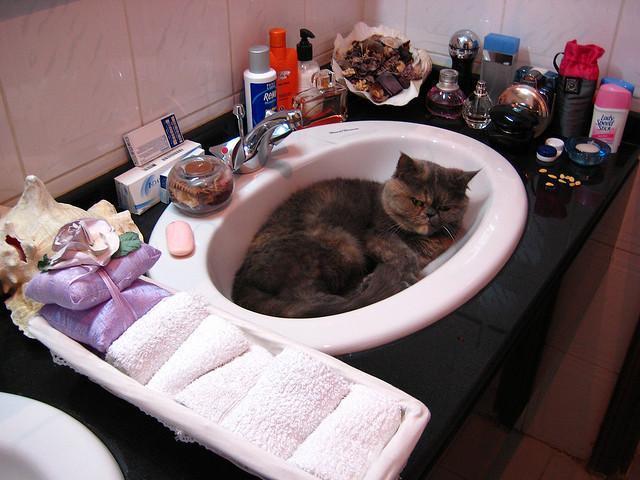How many bottles are in the picture?
Give a very brief answer. 2. How many clocks are there?
Give a very brief answer. 0. 